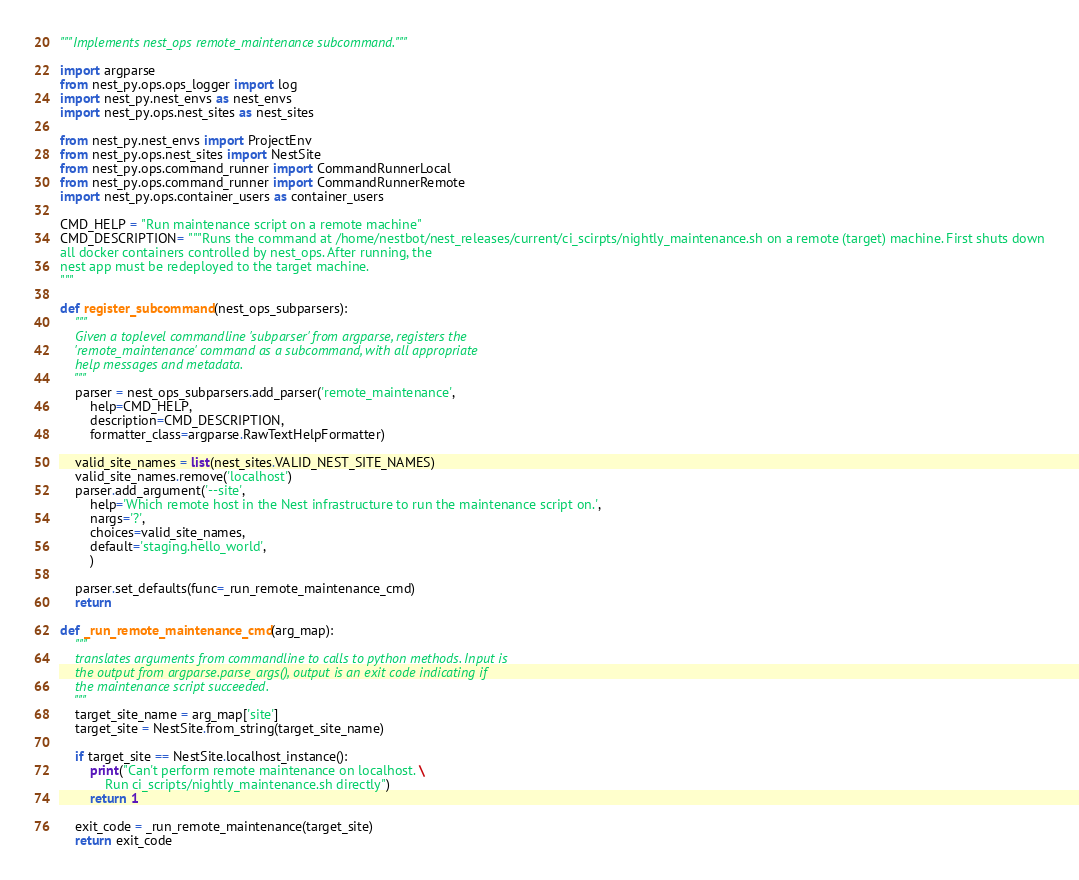<code> <loc_0><loc_0><loc_500><loc_500><_Python_>"""Implements nest_ops remote_maintenance subcommand."""

import argparse
from nest_py.ops.ops_logger import log
import nest_py.nest_envs as nest_envs
import nest_py.ops.nest_sites as nest_sites

from nest_py.nest_envs import ProjectEnv
from nest_py.ops.nest_sites import NestSite
from nest_py.ops.command_runner import CommandRunnerLocal
from nest_py.ops.command_runner import CommandRunnerRemote
import nest_py.ops.container_users as container_users

CMD_HELP = "Run maintenance script on a remote machine"
CMD_DESCRIPTION= """Runs the command at /home/nestbot/nest_releases/current/ci_scirpts/nightly_maintenance.sh on a remote (target) machine. First shuts down
all docker containers controlled by nest_ops. After running, the
nest app must be redeployed to the target machine.
"""

def register_subcommand(nest_ops_subparsers):
    """
    Given a toplevel commandline 'subparser' from argparse, registers the
    'remote_maintenance' command as a subcommand, with all appropriate 
    help messages and metadata.
    """
    parser = nest_ops_subparsers.add_parser('remote_maintenance', 
        help=CMD_HELP, 
        description=CMD_DESCRIPTION, 
        formatter_class=argparse.RawTextHelpFormatter)

    valid_site_names = list(nest_sites.VALID_NEST_SITE_NAMES)
    valid_site_names.remove('localhost')
    parser.add_argument('--site',
        help='Which remote host in the Nest infrastructure to run the maintenance script on.',
        nargs='?',
        choices=valid_site_names,
        default='staging.hello_world',
        )

    parser.set_defaults(func=_run_remote_maintenance_cmd)
    return

def _run_remote_maintenance_cmd(arg_map):
    """
    translates arguments from commandline to calls to python methods. Input is
    the output from argparse.parse_args(), output is an exit code indicating if
    the maintenance script succeeded.
    """
    target_site_name = arg_map['site']
    target_site = NestSite.from_string(target_site_name)

    if target_site == NestSite.localhost_instance():
        print("Can't perform remote maintenance on localhost. \
            Run ci_scripts/nightly_maintenance.sh directly")
        return 1

    exit_code = _run_remote_maintenance(target_site)
    return exit_code
</code> 